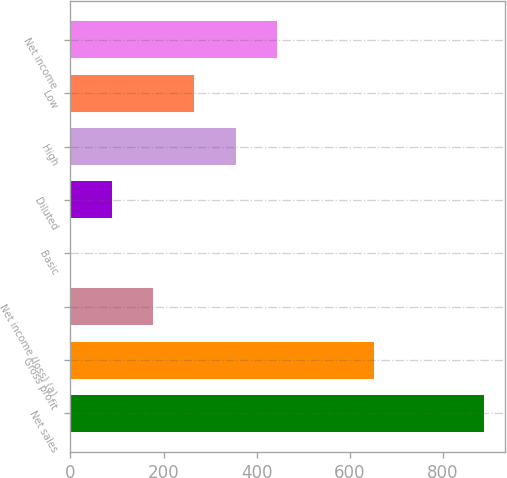Convert chart to OTSL. <chart><loc_0><loc_0><loc_500><loc_500><bar_chart><fcel>Net sales<fcel>Gross profit<fcel>Net income (loss) (a)<fcel>Basic<fcel>Diluted<fcel>High<fcel>Low<fcel>Net income<nl><fcel>888.5<fcel>653.2<fcel>177.71<fcel>0.01<fcel>88.86<fcel>355.41<fcel>266.56<fcel>444.26<nl></chart> 